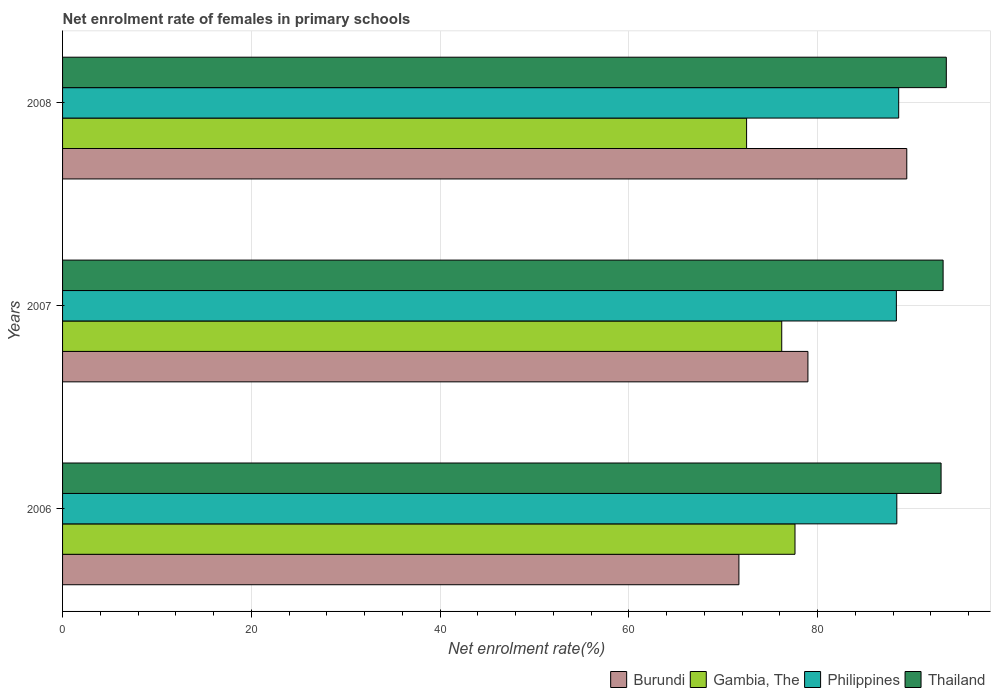How many different coloured bars are there?
Your answer should be very brief. 4. How many groups of bars are there?
Keep it short and to the point. 3. Are the number of bars per tick equal to the number of legend labels?
Give a very brief answer. Yes. Are the number of bars on each tick of the Y-axis equal?
Provide a short and direct response. Yes. How many bars are there on the 3rd tick from the top?
Provide a succinct answer. 4. What is the label of the 3rd group of bars from the top?
Keep it short and to the point. 2006. What is the net enrolment rate of females in primary schools in Thailand in 2006?
Ensure brevity in your answer.  93.07. Across all years, what is the maximum net enrolment rate of females in primary schools in Gambia, The?
Keep it short and to the point. 77.59. Across all years, what is the minimum net enrolment rate of females in primary schools in Thailand?
Your answer should be compact. 93.07. In which year was the net enrolment rate of females in primary schools in Philippines minimum?
Make the answer very short. 2007. What is the total net enrolment rate of females in primary schools in Philippines in the graph?
Offer a very short reply. 265.29. What is the difference between the net enrolment rate of females in primary schools in Philippines in 2006 and that in 2007?
Offer a very short reply. 0.05. What is the difference between the net enrolment rate of females in primary schools in Burundi in 2008 and the net enrolment rate of females in primary schools in Philippines in 2007?
Make the answer very short. 1.1. What is the average net enrolment rate of females in primary schools in Gambia, The per year?
Your response must be concise. 75.42. In the year 2007, what is the difference between the net enrolment rate of females in primary schools in Gambia, The and net enrolment rate of females in primary schools in Thailand?
Your response must be concise. -17.1. What is the ratio of the net enrolment rate of females in primary schools in Thailand in 2006 to that in 2008?
Offer a terse response. 0.99. Is the net enrolment rate of females in primary schools in Gambia, The in 2006 less than that in 2007?
Provide a short and direct response. No. Is the difference between the net enrolment rate of females in primary schools in Gambia, The in 2007 and 2008 greater than the difference between the net enrolment rate of females in primary schools in Thailand in 2007 and 2008?
Your response must be concise. Yes. What is the difference between the highest and the second highest net enrolment rate of females in primary schools in Thailand?
Your answer should be compact. 0.34. What is the difference between the highest and the lowest net enrolment rate of females in primary schools in Thailand?
Offer a very short reply. 0.55. What does the 2nd bar from the bottom in 2006 represents?
Ensure brevity in your answer.  Gambia, The. Are all the bars in the graph horizontal?
Your answer should be very brief. Yes. How many years are there in the graph?
Provide a succinct answer. 3. What is the difference between two consecutive major ticks on the X-axis?
Provide a succinct answer. 20. Are the values on the major ticks of X-axis written in scientific E-notation?
Keep it short and to the point. No. Does the graph contain any zero values?
Make the answer very short. No. How are the legend labels stacked?
Provide a short and direct response. Horizontal. What is the title of the graph?
Your answer should be very brief. Net enrolment rate of females in primary schools. Does "Nepal" appear as one of the legend labels in the graph?
Your response must be concise. No. What is the label or title of the X-axis?
Give a very brief answer. Net enrolment rate(%). What is the label or title of the Y-axis?
Provide a succinct answer. Years. What is the Net enrolment rate(%) of Burundi in 2006?
Give a very brief answer. 71.65. What is the Net enrolment rate(%) of Gambia, The in 2006?
Provide a succinct answer. 77.59. What is the Net enrolment rate(%) of Philippines in 2006?
Your answer should be compact. 88.38. What is the Net enrolment rate(%) of Thailand in 2006?
Your answer should be very brief. 93.07. What is the Net enrolment rate(%) in Burundi in 2007?
Your response must be concise. 78.96. What is the Net enrolment rate(%) in Gambia, The in 2007?
Make the answer very short. 76.19. What is the Net enrolment rate(%) of Philippines in 2007?
Make the answer very short. 88.33. What is the Net enrolment rate(%) in Thailand in 2007?
Your response must be concise. 93.28. What is the Net enrolment rate(%) of Burundi in 2008?
Make the answer very short. 89.44. What is the Net enrolment rate(%) in Gambia, The in 2008?
Give a very brief answer. 72.47. What is the Net enrolment rate(%) of Philippines in 2008?
Give a very brief answer. 88.58. What is the Net enrolment rate(%) of Thailand in 2008?
Your response must be concise. 93.62. Across all years, what is the maximum Net enrolment rate(%) in Burundi?
Your answer should be compact. 89.44. Across all years, what is the maximum Net enrolment rate(%) of Gambia, The?
Your answer should be compact. 77.59. Across all years, what is the maximum Net enrolment rate(%) of Philippines?
Give a very brief answer. 88.58. Across all years, what is the maximum Net enrolment rate(%) of Thailand?
Your response must be concise. 93.62. Across all years, what is the minimum Net enrolment rate(%) of Burundi?
Provide a succinct answer. 71.65. Across all years, what is the minimum Net enrolment rate(%) in Gambia, The?
Provide a short and direct response. 72.47. Across all years, what is the minimum Net enrolment rate(%) in Philippines?
Your answer should be compact. 88.33. Across all years, what is the minimum Net enrolment rate(%) of Thailand?
Provide a short and direct response. 93.07. What is the total Net enrolment rate(%) of Burundi in the graph?
Ensure brevity in your answer.  240.05. What is the total Net enrolment rate(%) in Gambia, The in the graph?
Give a very brief answer. 226.25. What is the total Net enrolment rate(%) of Philippines in the graph?
Your response must be concise. 265.29. What is the total Net enrolment rate(%) of Thailand in the graph?
Provide a succinct answer. 279.98. What is the difference between the Net enrolment rate(%) of Burundi in 2006 and that in 2007?
Offer a terse response. -7.31. What is the difference between the Net enrolment rate(%) in Gambia, The in 2006 and that in 2007?
Your answer should be compact. 1.41. What is the difference between the Net enrolment rate(%) in Philippines in 2006 and that in 2007?
Ensure brevity in your answer.  0.05. What is the difference between the Net enrolment rate(%) of Thailand in 2006 and that in 2007?
Provide a succinct answer. -0.22. What is the difference between the Net enrolment rate(%) of Burundi in 2006 and that in 2008?
Provide a succinct answer. -17.79. What is the difference between the Net enrolment rate(%) of Gambia, The in 2006 and that in 2008?
Provide a succinct answer. 5.13. What is the difference between the Net enrolment rate(%) in Philippines in 2006 and that in 2008?
Give a very brief answer. -0.2. What is the difference between the Net enrolment rate(%) of Thailand in 2006 and that in 2008?
Offer a very short reply. -0.55. What is the difference between the Net enrolment rate(%) of Burundi in 2007 and that in 2008?
Your answer should be compact. -10.47. What is the difference between the Net enrolment rate(%) in Gambia, The in 2007 and that in 2008?
Your answer should be very brief. 3.72. What is the difference between the Net enrolment rate(%) of Philippines in 2007 and that in 2008?
Give a very brief answer. -0.25. What is the difference between the Net enrolment rate(%) of Thailand in 2007 and that in 2008?
Offer a terse response. -0.34. What is the difference between the Net enrolment rate(%) in Burundi in 2006 and the Net enrolment rate(%) in Gambia, The in 2007?
Offer a terse response. -4.54. What is the difference between the Net enrolment rate(%) in Burundi in 2006 and the Net enrolment rate(%) in Philippines in 2007?
Your response must be concise. -16.68. What is the difference between the Net enrolment rate(%) in Burundi in 2006 and the Net enrolment rate(%) in Thailand in 2007?
Offer a terse response. -21.63. What is the difference between the Net enrolment rate(%) in Gambia, The in 2006 and the Net enrolment rate(%) in Philippines in 2007?
Your answer should be very brief. -10.74. What is the difference between the Net enrolment rate(%) of Gambia, The in 2006 and the Net enrolment rate(%) of Thailand in 2007?
Your response must be concise. -15.69. What is the difference between the Net enrolment rate(%) in Philippines in 2006 and the Net enrolment rate(%) in Thailand in 2007?
Offer a very short reply. -4.9. What is the difference between the Net enrolment rate(%) of Burundi in 2006 and the Net enrolment rate(%) of Gambia, The in 2008?
Keep it short and to the point. -0.82. What is the difference between the Net enrolment rate(%) of Burundi in 2006 and the Net enrolment rate(%) of Philippines in 2008?
Offer a very short reply. -16.93. What is the difference between the Net enrolment rate(%) in Burundi in 2006 and the Net enrolment rate(%) in Thailand in 2008?
Provide a succinct answer. -21.97. What is the difference between the Net enrolment rate(%) in Gambia, The in 2006 and the Net enrolment rate(%) in Philippines in 2008?
Your response must be concise. -10.98. What is the difference between the Net enrolment rate(%) of Gambia, The in 2006 and the Net enrolment rate(%) of Thailand in 2008?
Give a very brief answer. -16.03. What is the difference between the Net enrolment rate(%) in Philippines in 2006 and the Net enrolment rate(%) in Thailand in 2008?
Give a very brief answer. -5.24. What is the difference between the Net enrolment rate(%) in Burundi in 2007 and the Net enrolment rate(%) in Gambia, The in 2008?
Provide a succinct answer. 6.5. What is the difference between the Net enrolment rate(%) in Burundi in 2007 and the Net enrolment rate(%) in Philippines in 2008?
Offer a very short reply. -9.62. What is the difference between the Net enrolment rate(%) of Burundi in 2007 and the Net enrolment rate(%) of Thailand in 2008?
Offer a very short reply. -14.66. What is the difference between the Net enrolment rate(%) in Gambia, The in 2007 and the Net enrolment rate(%) in Philippines in 2008?
Your response must be concise. -12.39. What is the difference between the Net enrolment rate(%) in Gambia, The in 2007 and the Net enrolment rate(%) in Thailand in 2008?
Your answer should be very brief. -17.43. What is the difference between the Net enrolment rate(%) in Philippines in 2007 and the Net enrolment rate(%) in Thailand in 2008?
Ensure brevity in your answer.  -5.29. What is the average Net enrolment rate(%) of Burundi per year?
Your answer should be compact. 80.02. What is the average Net enrolment rate(%) in Gambia, The per year?
Ensure brevity in your answer.  75.42. What is the average Net enrolment rate(%) of Philippines per year?
Your answer should be compact. 88.43. What is the average Net enrolment rate(%) of Thailand per year?
Give a very brief answer. 93.33. In the year 2006, what is the difference between the Net enrolment rate(%) of Burundi and Net enrolment rate(%) of Gambia, The?
Make the answer very short. -5.94. In the year 2006, what is the difference between the Net enrolment rate(%) in Burundi and Net enrolment rate(%) in Philippines?
Your answer should be compact. -16.73. In the year 2006, what is the difference between the Net enrolment rate(%) of Burundi and Net enrolment rate(%) of Thailand?
Offer a terse response. -21.42. In the year 2006, what is the difference between the Net enrolment rate(%) of Gambia, The and Net enrolment rate(%) of Philippines?
Ensure brevity in your answer.  -10.79. In the year 2006, what is the difference between the Net enrolment rate(%) of Gambia, The and Net enrolment rate(%) of Thailand?
Offer a very short reply. -15.48. In the year 2006, what is the difference between the Net enrolment rate(%) of Philippines and Net enrolment rate(%) of Thailand?
Your answer should be very brief. -4.69. In the year 2007, what is the difference between the Net enrolment rate(%) in Burundi and Net enrolment rate(%) in Gambia, The?
Your response must be concise. 2.77. In the year 2007, what is the difference between the Net enrolment rate(%) in Burundi and Net enrolment rate(%) in Philippines?
Offer a very short reply. -9.37. In the year 2007, what is the difference between the Net enrolment rate(%) of Burundi and Net enrolment rate(%) of Thailand?
Your answer should be compact. -14.32. In the year 2007, what is the difference between the Net enrolment rate(%) in Gambia, The and Net enrolment rate(%) in Philippines?
Ensure brevity in your answer.  -12.14. In the year 2007, what is the difference between the Net enrolment rate(%) in Gambia, The and Net enrolment rate(%) in Thailand?
Make the answer very short. -17.1. In the year 2007, what is the difference between the Net enrolment rate(%) in Philippines and Net enrolment rate(%) in Thailand?
Your answer should be compact. -4.95. In the year 2008, what is the difference between the Net enrolment rate(%) of Burundi and Net enrolment rate(%) of Gambia, The?
Offer a terse response. 16.97. In the year 2008, what is the difference between the Net enrolment rate(%) of Burundi and Net enrolment rate(%) of Philippines?
Provide a short and direct response. 0.86. In the year 2008, what is the difference between the Net enrolment rate(%) of Burundi and Net enrolment rate(%) of Thailand?
Offer a terse response. -4.19. In the year 2008, what is the difference between the Net enrolment rate(%) of Gambia, The and Net enrolment rate(%) of Philippines?
Offer a very short reply. -16.11. In the year 2008, what is the difference between the Net enrolment rate(%) of Gambia, The and Net enrolment rate(%) of Thailand?
Keep it short and to the point. -21.16. In the year 2008, what is the difference between the Net enrolment rate(%) of Philippines and Net enrolment rate(%) of Thailand?
Ensure brevity in your answer.  -5.04. What is the ratio of the Net enrolment rate(%) in Burundi in 2006 to that in 2007?
Your answer should be very brief. 0.91. What is the ratio of the Net enrolment rate(%) in Gambia, The in 2006 to that in 2007?
Your answer should be very brief. 1.02. What is the ratio of the Net enrolment rate(%) of Thailand in 2006 to that in 2007?
Ensure brevity in your answer.  1. What is the ratio of the Net enrolment rate(%) in Burundi in 2006 to that in 2008?
Offer a terse response. 0.8. What is the ratio of the Net enrolment rate(%) in Gambia, The in 2006 to that in 2008?
Ensure brevity in your answer.  1.07. What is the ratio of the Net enrolment rate(%) of Burundi in 2007 to that in 2008?
Your response must be concise. 0.88. What is the ratio of the Net enrolment rate(%) in Gambia, The in 2007 to that in 2008?
Your response must be concise. 1.05. What is the ratio of the Net enrolment rate(%) in Thailand in 2007 to that in 2008?
Make the answer very short. 1. What is the difference between the highest and the second highest Net enrolment rate(%) of Burundi?
Your answer should be very brief. 10.47. What is the difference between the highest and the second highest Net enrolment rate(%) in Gambia, The?
Provide a short and direct response. 1.41. What is the difference between the highest and the second highest Net enrolment rate(%) of Philippines?
Keep it short and to the point. 0.2. What is the difference between the highest and the second highest Net enrolment rate(%) in Thailand?
Offer a very short reply. 0.34. What is the difference between the highest and the lowest Net enrolment rate(%) of Burundi?
Make the answer very short. 17.79. What is the difference between the highest and the lowest Net enrolment rate(%) in Gambia, The?
Your response must be concise. 5.13. What is the difference between the highest and the lowest Net enrolment rate(%) of Philippines?
Offer a terse response. 0.25. What is the difference between the highest and the lowest Net enrolment rate(%) of Thailand?
Provide a short and direct response. 0.55. 